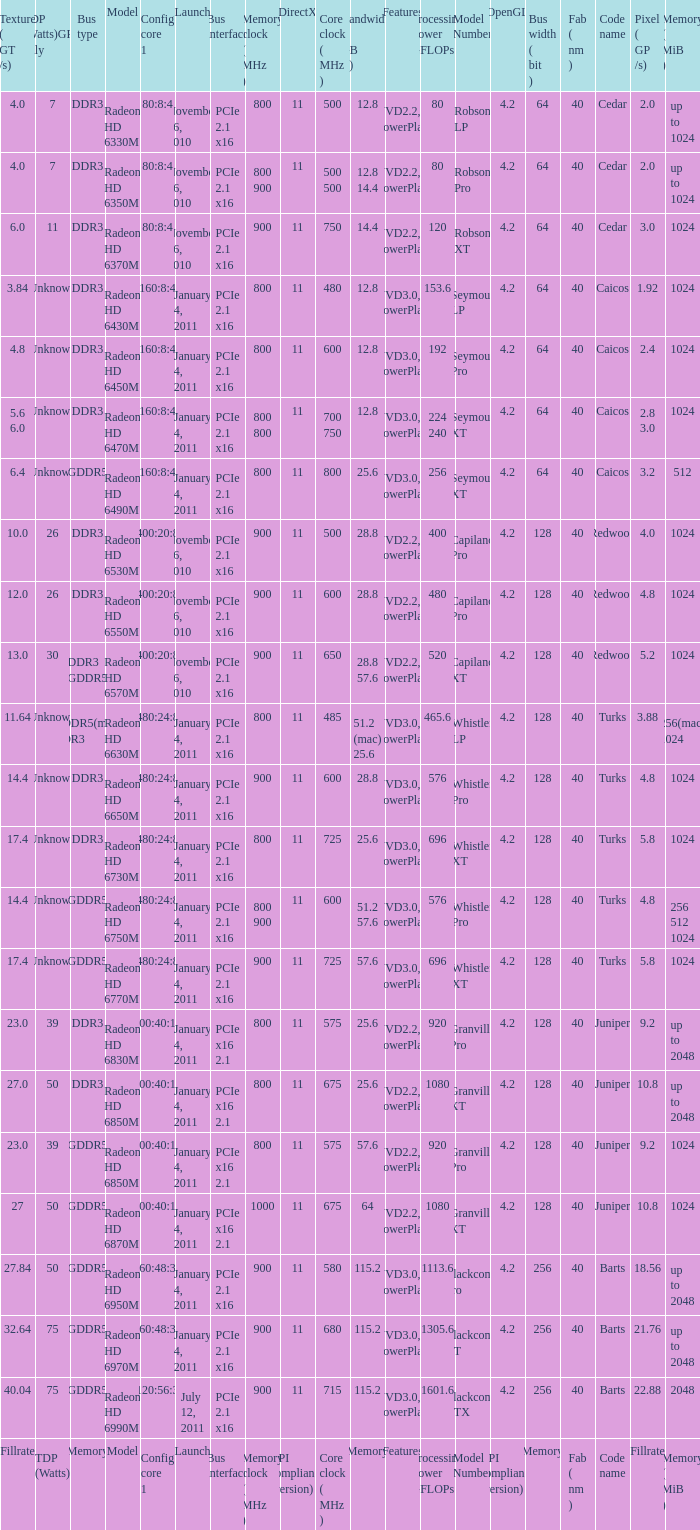How many values for bus width have a bandwidth of 25.6 and model number of Granville Pro? 1.0. 